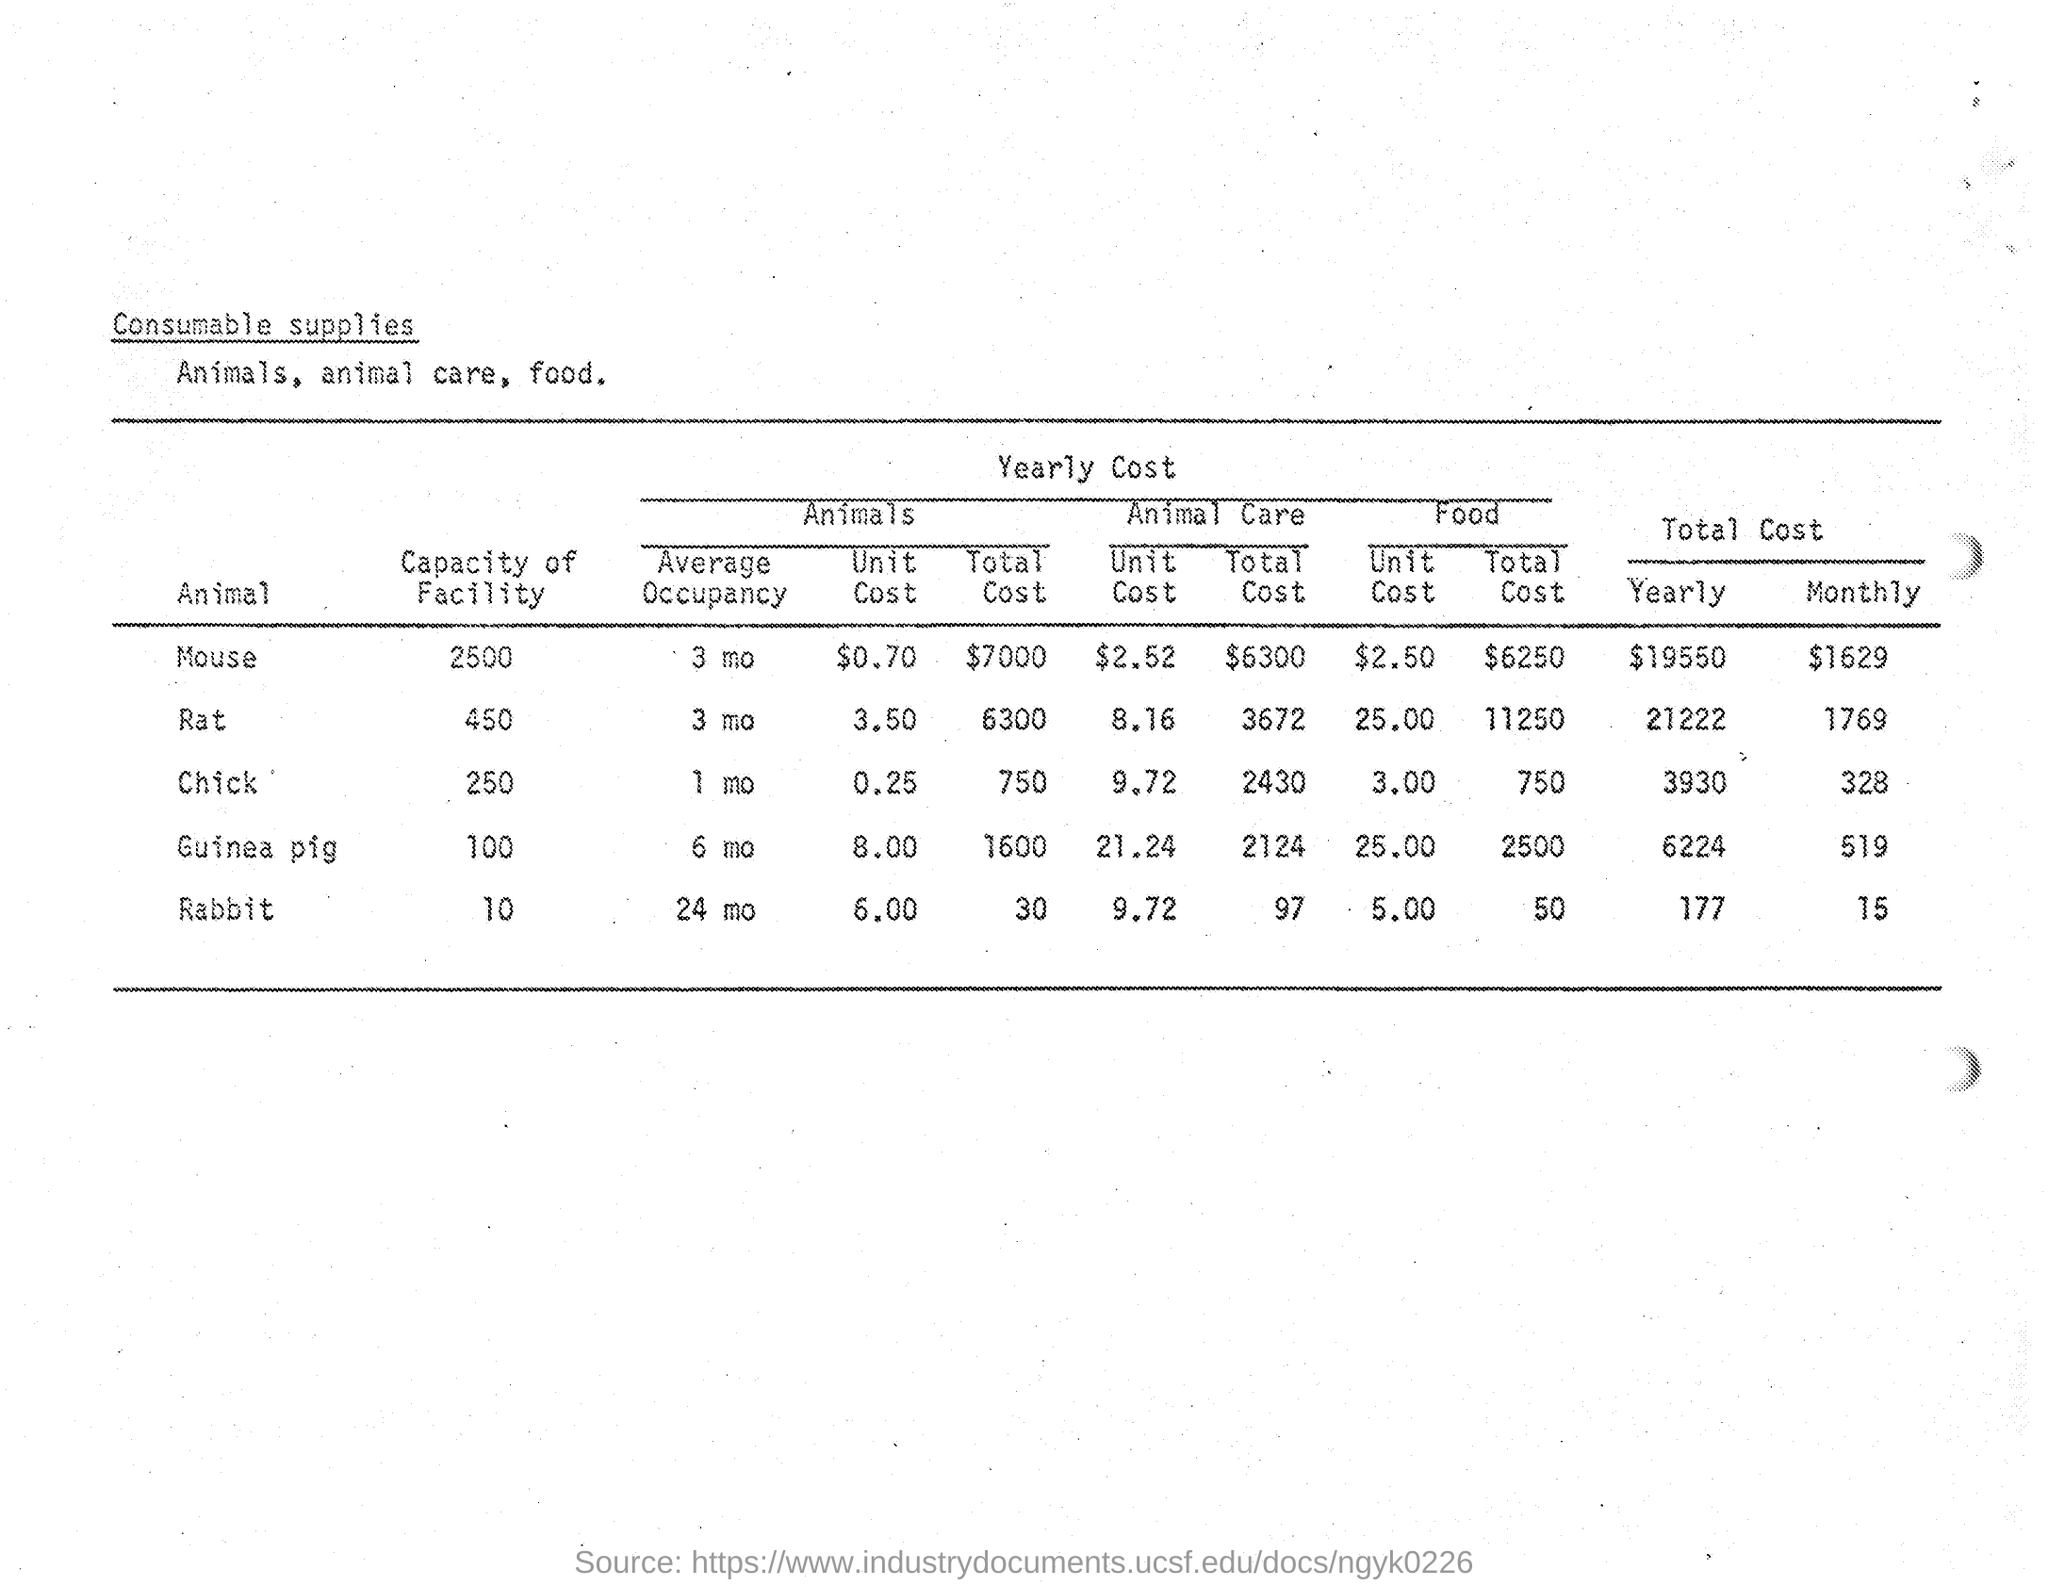How much is the total monthly cost of Mouse?
Provide a succinct answer. 1629$. How much is the average occupancy of the Chick?
Make the answer very short. 1 mo. 